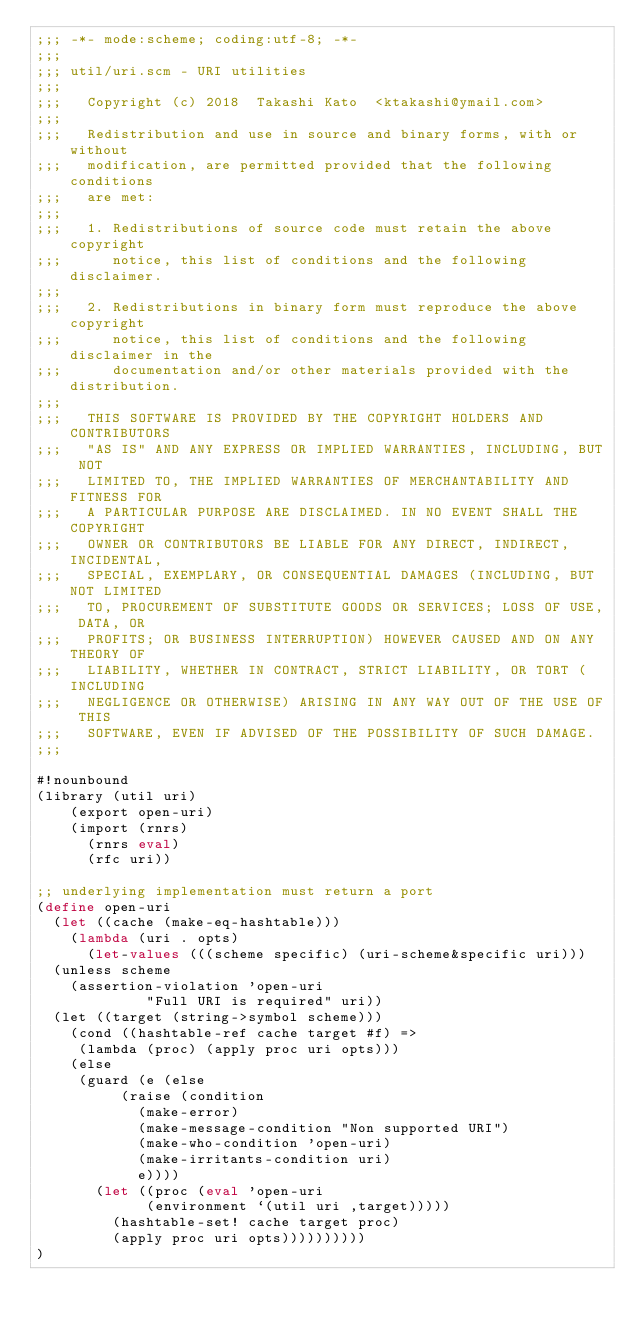Convert code to text. <code><loc_0><loc_0><loc_500><loc_500><_Scheme_>;;; -*- mode:scheme; coding:utf-8; -*-
;;;
;;; util/uri.scm - URI utilities
;;;
;;;   Copyright (c) 2018  Takashi Kato  <ktakashi@ymail.com>
;;;
;;;   Redistribution and use in source and binary forms, with or without
;;;   modification, are permitted provided that the following conditions
;;;   are met:
;;;
;;;   1. Redistributions of source code must retain the above copyright
;;;      notice, this list of conditions and the following disclaimer.
;;;
;;;   2. Redistributions in binary form must reproduce the above copyright
;;;      notice, this list of conditions and the following disclaimer in the
;;;      documentation and/or other materials provided with the distribution.
;;;
;;;   THIS SOFTWARE IS PROVIDED BY THE COPYRIGHT HOLDERS AND CONTRIBUTORS
;;;   "AS IS" AND ANY EXPRESS OR IMPLIED WARRANTIES, INCLUDING, BUT NOT
;;;   LIMITED TO, THE IMPLIED WARRANTIES OF MERCHANTABILITY AND FITNESS FOR
;;;   A PARTICULAR PURPOSE ARE DISCLAIMED. IN NO EVENT SHALL THE COPYRIGHT
;;;   OWNER OR CONTRIBUTORS BE LIABLE FOR ANY DIRECT, INDIRECT, INCIDENTAL,
;;;   SPECIAL, EXEMPLARY, OR CONSEQUENTIAL DAMAGES (INCLUDING, BUT NOT LIMITED
;;;   TO, PROCUREMENT OF SUBSTITUTE GOODS OR SERVICES; LOSS OF USE, DATA, OR
;;;   PROFITS; OR BUSINESS INTERRUPTION) HOWEVER CAUSED AND ON ANY THEORY OF
;;;   LIABILITY, WHETHER IN CONTRACT, STRICT LIABILITY, OR TORT (INCLUDING
;;;   NEGLIGENCE OR OTHERWISE) ARISING IN ANY WAY OUT OF THE USE OF THIS
;;;   SOFTWARE, EVEN IF ADVISED OF THE POSSIBILITY OF SUCH DAMAGE.
;;;

#!nounbound
(library (util uri)
    (export open-uri)
    (import (rnrs)
	    (rnrs eval)
	    (rfc uri))

;; underlying implementation must return a port
(define open-uri
  (let ((cache (make-eq-hashtable)))
    (lambda (uri . opts)
      (let-values (((scheme specific) (uri-scheme&specific uri)))
	(unless scheme
	  (assertion-violation 'open-uri
			       "Full URI is required" uri))
	(let ((target (string->symbol scheme)))
	  (cond ((hashtable-ref cache target #f) =>
		 (lambda (proc) (apply proc uri opts)))
		(else
		 (guard (e (else
			    (raise (condition 
				    (make-error)
				    (make-message-condition "Non supported URI")
				    (make-who-condition 'open-uri)
				    (make-irritants-condition uri)
				    e))))
		   (let ((proc (eval 'open-uri
				     (environment `(util uri ,target)))))
		     (hashtable-set! cache target proc)
		     (apply proc uri opts))))))))))
)
</code> 